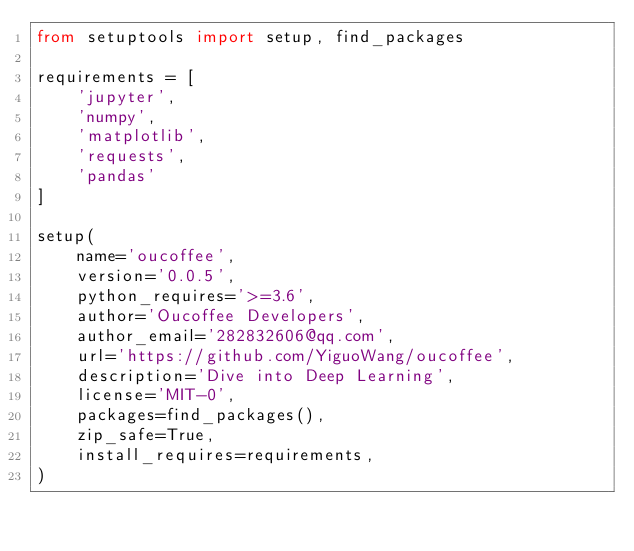<code> <loc_0><loc_0><loc_500><loc_500><_Python_>from setuptools import setup, find_packages

requirements = [
    'jupyter',
    'numpy',
    'matplotlib',
    'requests',
    'pandas'
]

setup(
    name='oucoffee',
    version='0.0.5',
    python_requires='>=3.6',
    author='Oucoffee Developers',
    author_email='282832606@qq.com',
    url='https://github.com/YiguoWang/oucoffee',
    description='Dive into Deep Learning',
    license='MIT-0',
    packages=find_packages(),
    zip_safe=True,
    install_requires=requirements,
)
</code> 